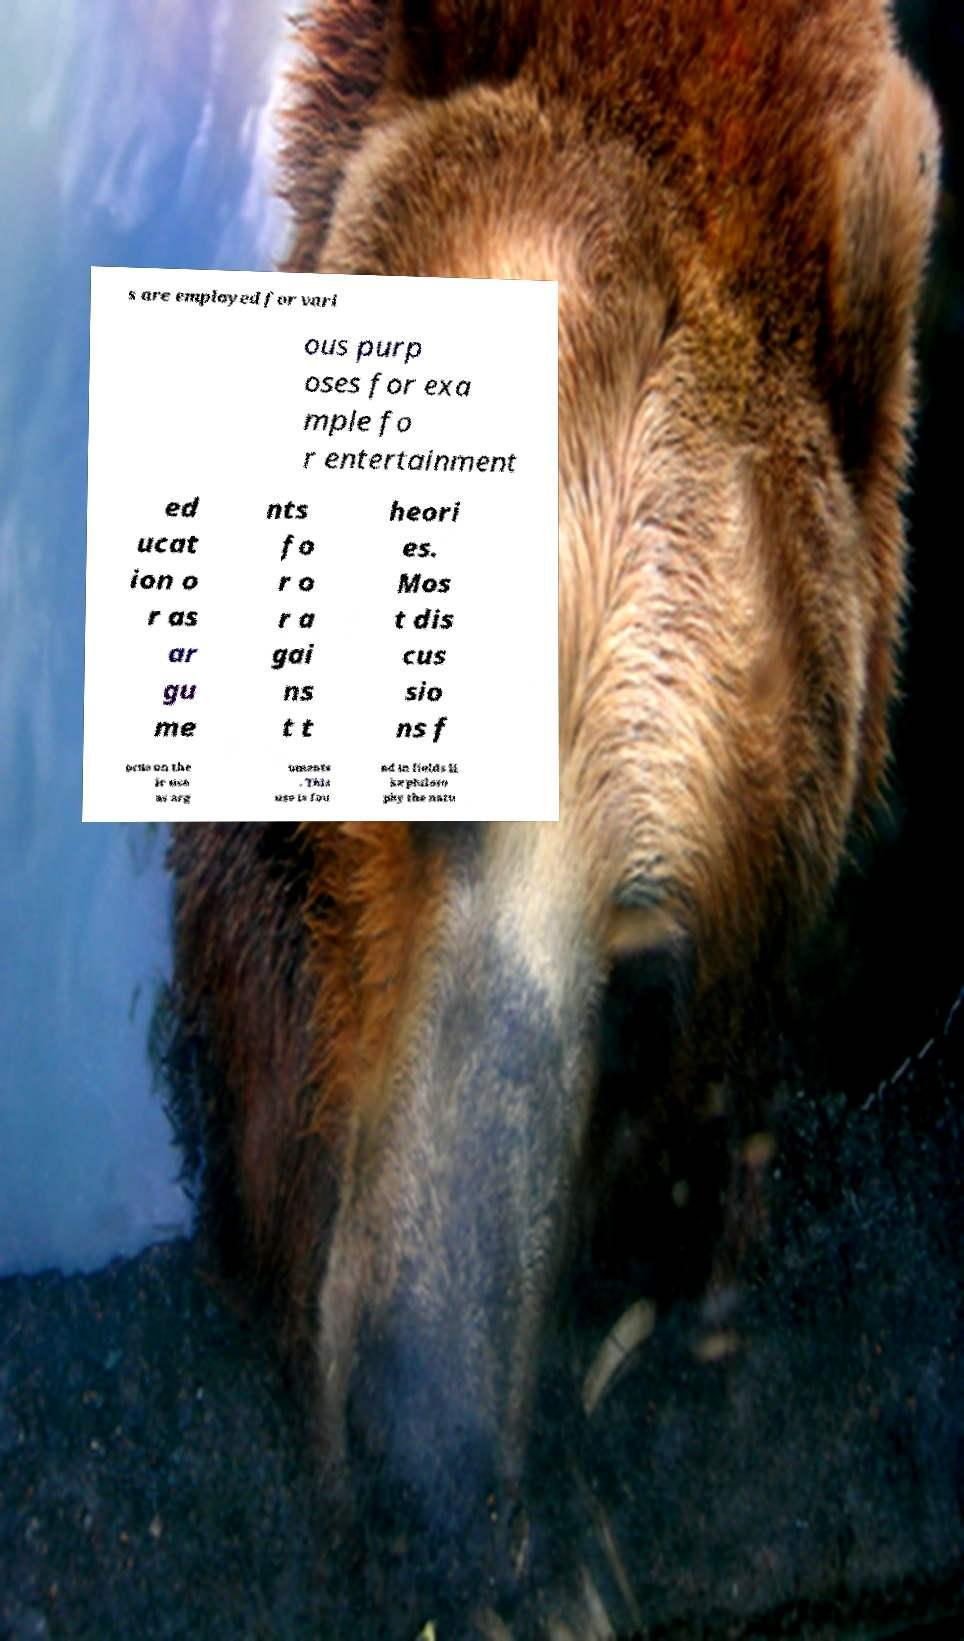Could you assist in decoding the text presented in this image and type it out clearly? s are employed for vari ous purp oses for exa mple fo r entertainment ed ucat ion o r as ar gu me nts fo r o r a gai ns t t heori es. Mos t dis cus sio ns f ocus on the ir use as arg uments . This use is fou nd in fields li ke philoso phy the natu 